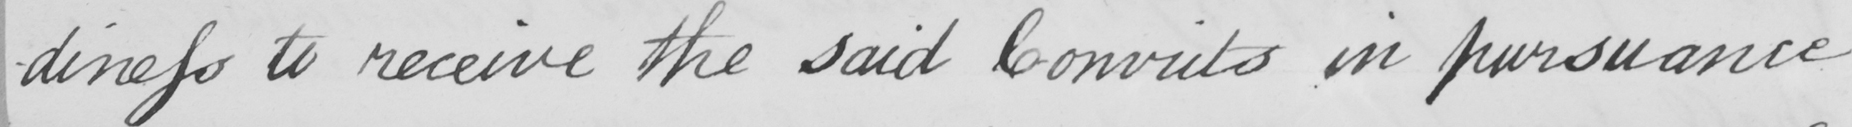Transcribe the text shown in this historical manuscript line. -diness to receive the said Convicts in pursuance 